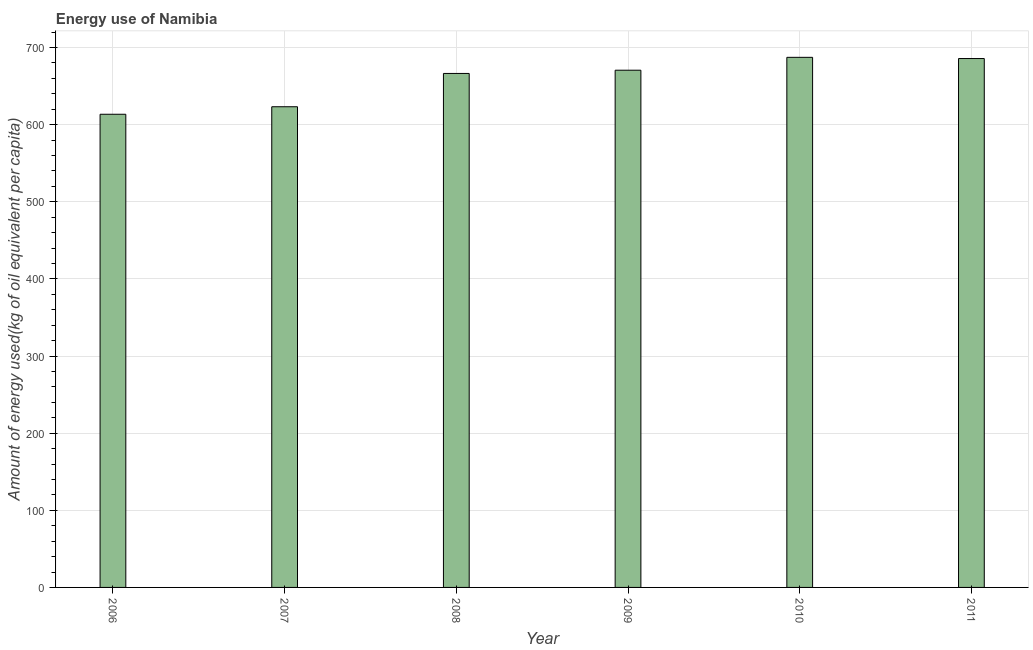What is the title of the graph?
Your response must be concise. Energy use of Namibia. What is the label or title of the X-axis?
Your answer should be very brief. Year. What is the label or title of the Y-axis?
Your answer should be very brief. Amount of energy used(kg of oil equivalent per capita). What is the amount of energy used in 2007?
Ensure brevity in your answer.  623.23. Across all years, what is the maximum amount of energy used?
Your answer should be compact. 687.3. Across all years, what is the minimum amount of energy used?
Your answer should be very brief. 613.5. In which year was the amount of energy used maximum?
Provide a short and direct response. 2010. What is the sum of the amount of energy used?
Offer a terse response. 3946.76. What is the difference between the amount of energy used in 2006 and 2007?
Your answer should be very brief. -9.74. What is the average amount of energy used per year?
Make the answer very short. 657.79. What is the median amount of energy used?
Keep it short and to the point. 668.5. Do a majority of the years between 2009 and 2006 (inclusive) have amount of energy used greater than 140 kg?
Provide a short and direct response. Yes. What is the ratio of the amount of energy used in 2006 to that in 2011?
Your answer should be very brief. 0.9. What is the difference between the highest and the second highest amount of energy used?
Your answer should be very brief. 1.57. What is the difference between the highest and the lowest amount of energy used?
Give a very brief answer. 73.8. How many bars are there?
Give a very brief answer. 6. What is the difference between two consecutive major ticks on the Y-axis?
Keep it short and to the point. 100. What is the Amount of energy used(kg of oil equivalent per capita) of 2006?
Your answer should be compact. 613.5. What is the Amount of energy used(kg of oil equivalent per capita) in 2007?
Offer a terse response. 623.23. What is the Amount of energy used(kg of oil equivalent per capita) of 2008?
Provide a short and direct response. 666.4. What is the Amount of energy used(kg of oil equivalent per capita) of 2009?
Make the answer very short. 670.59. What is the Amount of energy used(kg of oil equivalent per capita) of 2010?
Give a very brief answer. 687.3. What is the Amount of energy used(kg of oil equivalent per capita) in 2011?
Offer a terse response. 685.73. What is the difference between the Amount of energy used(kg of oil equivalent per capita) in 2006 and 2007?
Your answer should be compact. -9.74. What is the difference between the Amount of energy used(kg of oil equivalent per capita) in 2006 and 2008?
Provide a succinct answer. -52.91. What is the difference between the Amount of energy used(kg of oil equivalent per capita) in 2006 and 2009?
Make the answer very short. -57.1. What is the difference between the Amount of energy used(kg of oil equivalent per capita) in 2006 and 2010?
Offer a very short reply. -73.8. What is the difference between the Amount of energy used(kg of oil equivalent per capita) in 2006 and 2011?
Your response must be concise. -72.24. What is the difference between the Amount of energy used(kg of oil equivalent per capita) in 2007 and 2008?
Keep it short and to the point. -43.17. What is the difference between the Amount of energy used(kg of oil equivalent per capita) in 2007 and 2009?
Your answer should be compact. -47.36. What is the difference between the Amount of energy used(kg of oil equivalent per capita) in 2007 and 2010?
Offer a very short reply. -64.07. What is the difference between the Amount of energy used(kg of oil equivalent per capita) in 2007 and 2011?
Offer a terse response. -62.5. What is the difference between the Amount of energy used(kg of oil equivalent per capita) in 2008 and 2009?
Make the answer very short. -4.19. What is the difference between the Amount of energy used(kg of oil equivalent per capita) in 2008 and 2010?
Provide a succinct answer. -20.9. What is the difference between the Amount of energy used(kg of oil equivalent per capita) in 2008 and 2011?
Offer a terse response. -19.33. What is the difference between the Amount of energy used(kg of oil equivalent per capita) in 2009 and 2010?
Offer a very short reply. -16.71. What is the difference between the Amount of energy used(kg of oil equivalent per capita) in 2009 and 2011?
Ensure brevity in your answer.  -15.14. What is the difference between the Amount of energy used(kg of oil equivalent per capita) in 2010 and 2011?
Offer a terse response. 1.57. What is the ratio of the Amount of energy used(kg of oil equivalent per capita) in 2006 to that in 2007?
Keep it short and to the point. 0.98. What is the ratio of the Amount of energy used(kg of oil equivalent per capita) in 2006 to that in 2008?
Make the answer very short. 0.92. What is the ratio of the Amount of energy used(kg of oil equivalent per capita) in 2006 to that in 2009?
Your response must be concise. 0.92. What is the ratio of the Amount of energy used(kg of oil equivalent per capita) in 2006 to that in 2010?
Give a very brief answer. 0.89. What is the ratio of the Amount of energy used(kg of oil equivalent per capita) in 2006 to that in 2011?
Your answer should be very brief. 0.9. What is the ratio of the Amount of energy used(kg of oil equivalent per capita) in 2007 to that in 2008?
Keep it short and to the point. 0.94. What is the ratio of the Amount of energy used(kg of oil equivalent per capita) in 2007 to that in 2009?
Your answer should be very brief. 0.93. What is the ratio of the Amount of energy used(kg of oil equivalent per capita) in 2007 to that in 2010?
Ensure brevity in your answer.  0.91. What is the ratio of the Amount of energy used(kg of oil equivalent per capita) in 2007 to that in 2011?
Give a very brief answer. 0.91. What is the ratio of the Amount of energy used(kg of oil equivalent per capita) in 2008 to that in 2009?
Offer a terse response. 0.99. What is the ratio of the Amount of energy used(kg of oil equivalent per capita) in 2008 to that in 2010?
Keep it short and to the point. 0.97. What is the ratio of the Amount of energy used(kg of oil equivalent per capita) in 2008 to that in 2011?
Provide a succinct answer. 0.97. What is the ratio of the Amount of energy used(kg of oil equivalent per capita) in 2010 to that in 2011?
Keep it short and to the point. 1. 